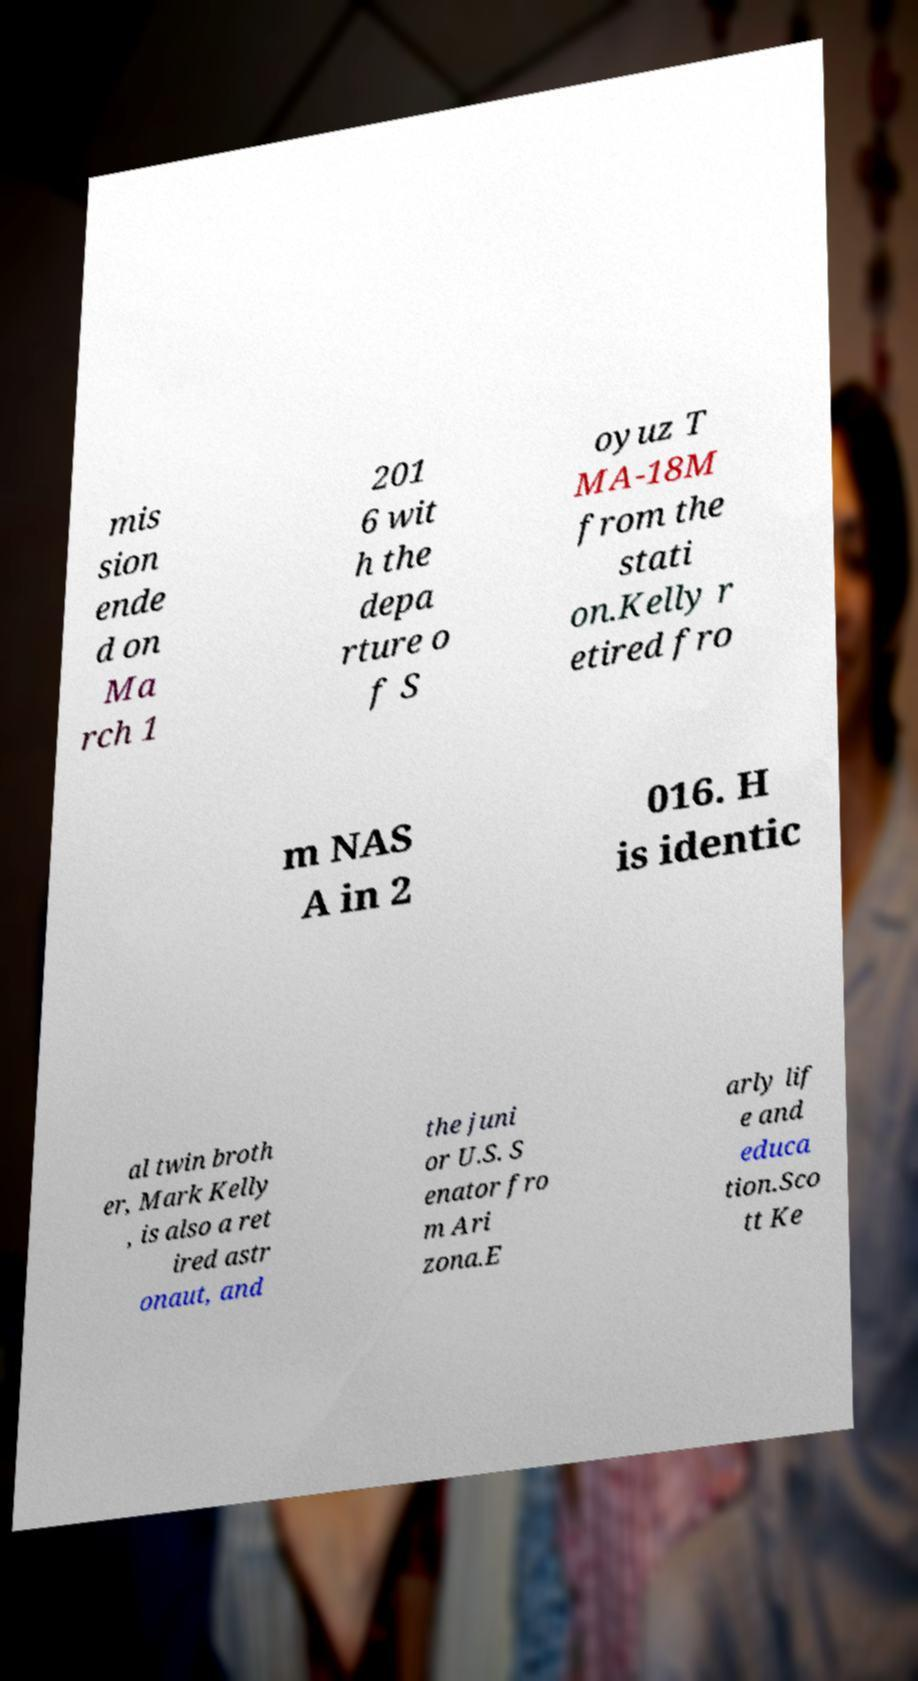Can you read and provide the text displayed in the image?This photo seems to have some interesting text. Can you extract and type it out for me? mis sion ende d on Ma rch 1 201 6 wit h the depa rture o f S oyuz T MA-18M from the stati on.Kelly r etired fro m NAS A in 2 016. H is identic al twin broth er, Mark Kelly , is also a ret ired astr onaut, and the juni or U.S. S enator fro m Ari zona.E arly lif e and educa tion.Sco tt Ke 